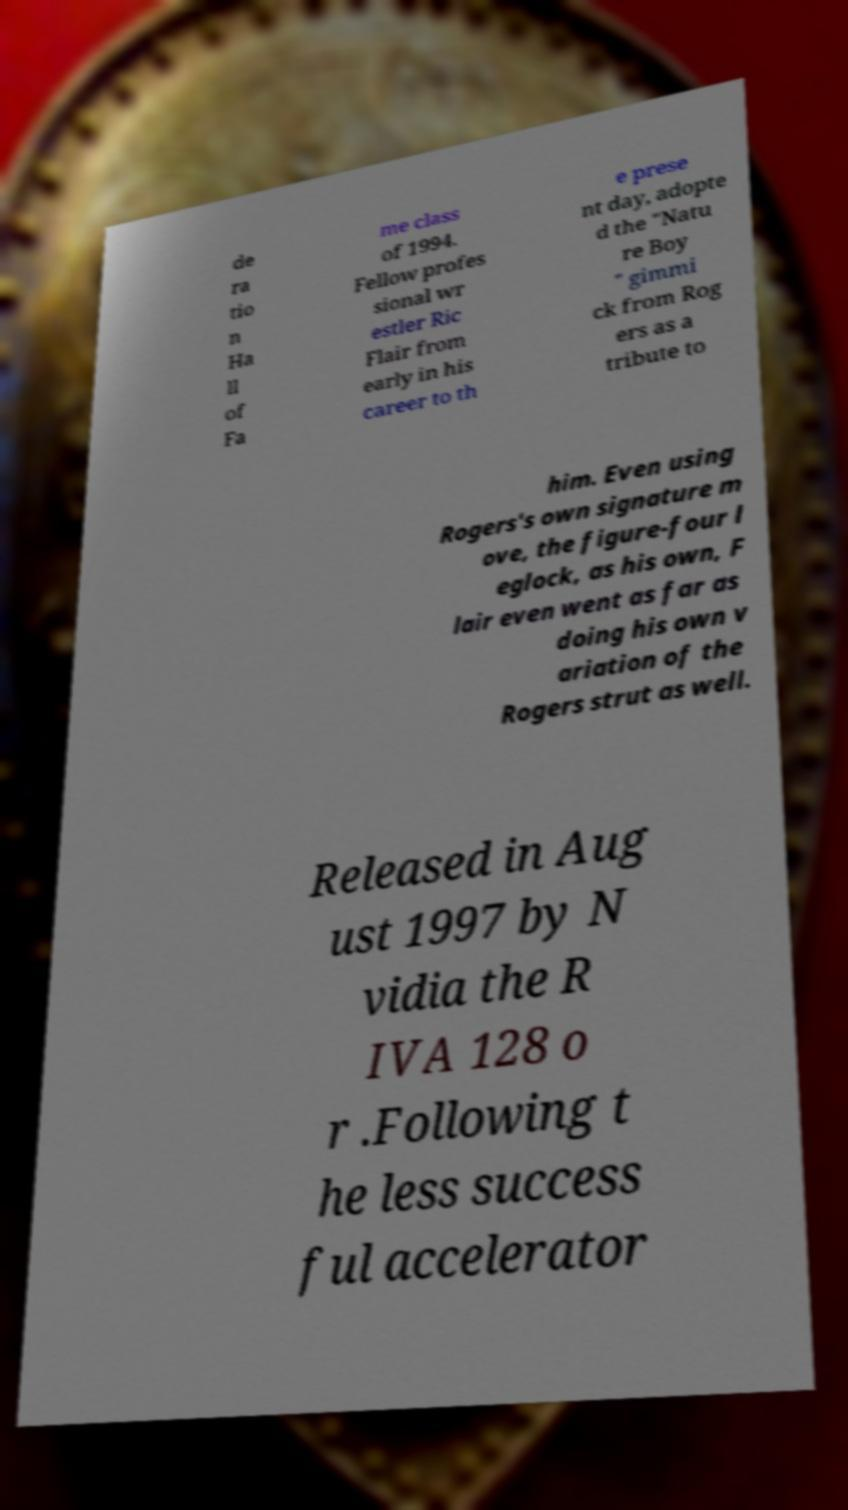Could you assist in decoding the text presented in this image and type it out clearly? de ra tio n Ha ll of Fa me class of 1994. Fellow profes sional wr estler Ric Flair from early in his career to th e prese nt day, adopte d the "Natu re Boy " gimmi ck from Rog ers as a tribute to him. Even using Rogers's own signature m ove, the figure-four l eglock, as his own, F lair even went as far as doing his own v ariation of the Rogers strut as well. Released in Aug ust 1997 by N vidia the R IVA 128 o r .Following t he less success ful accelerator 